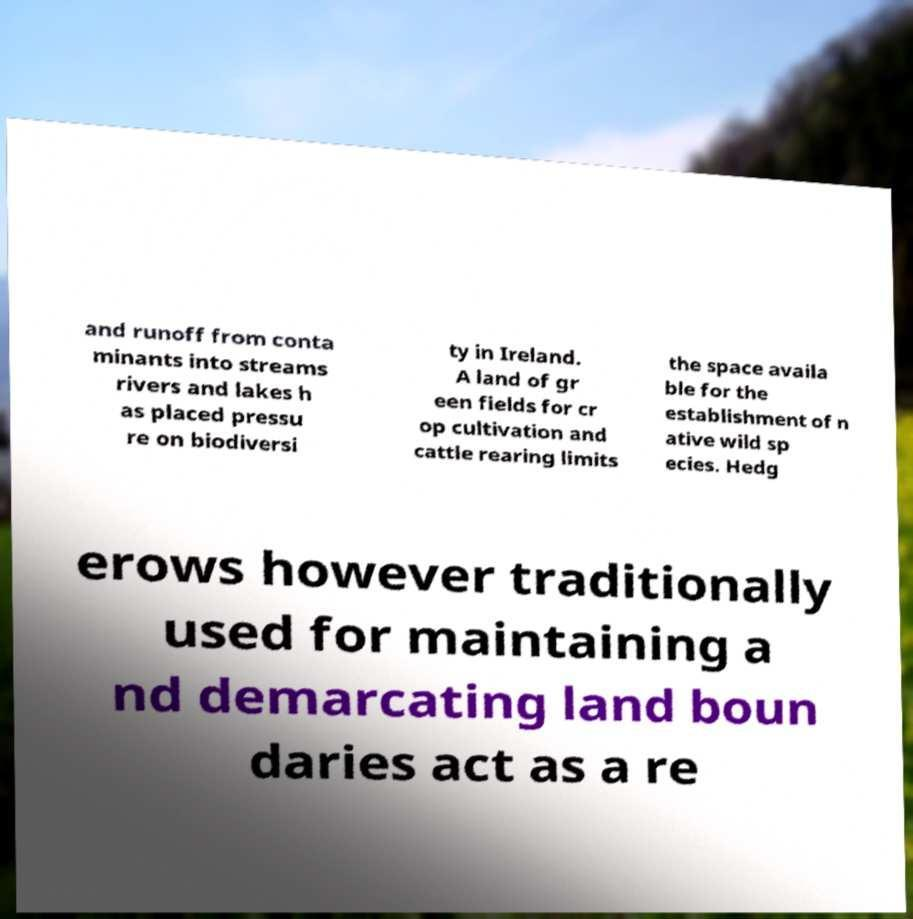I need the written content from this picture converted into text. Can you do that? and runoff from conta minants into streams rivers and lakes h as placed pressu re on biodiversi ty in Ireland. A land of gr een fields for cr op cultivation and cattle rearing limits the space availa ble for the establishment of n ative wild sp ecies. Hedg erows however traditionally used for maintaining a nd demarcating land boun daries act as a re 